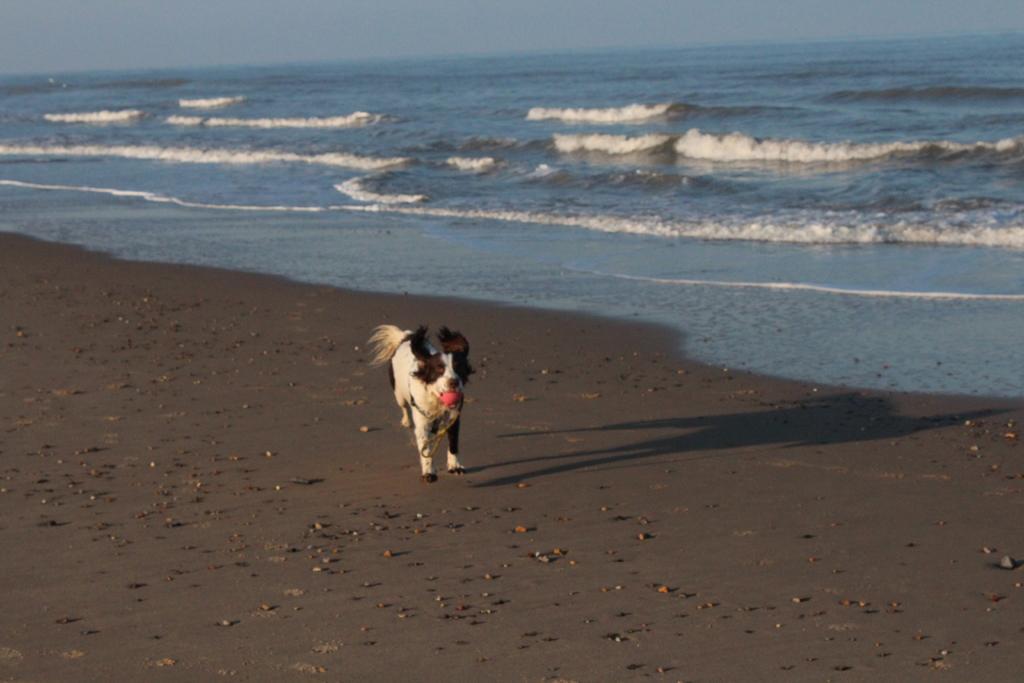Could you give a brief overview of what you see in this image? In this image we can see there is a dog on the ground. At the side there is the water and the sky. 